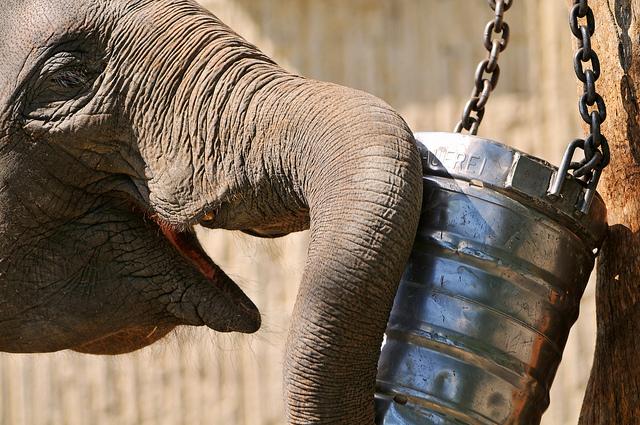Is the elephant eating?
Short answer required. Yes. Is the animal in the wild?
Answer briefly. No. What is hanging by a chain?
Be succinct. Bucket. 